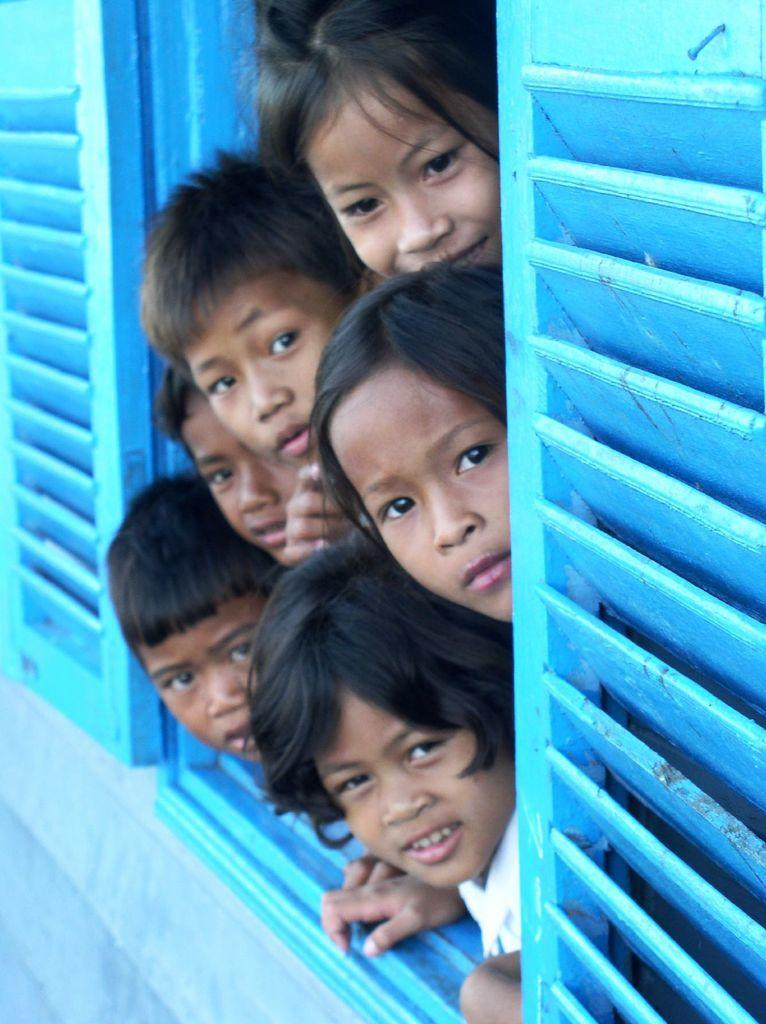What can be seen in the image that provides a view of the outside? There is a window in the image that provides a view of the outside. Who is present in the image? There are children in the image. How many tickets are visible in the image? There are no tickets present in the image. What part of the body is being used to hold the window in the image? The image does not show anyone holding the window, and there is no mention of elbows or any other body parts being used in this way. 